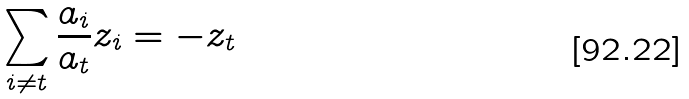<formula> <loc_0><loc_0><loc_500><loc_500>\sum _ { i \neq t } \frac { a _ { i } } { a _ { t } } z _ { i } = - z _ { t }</formula> 